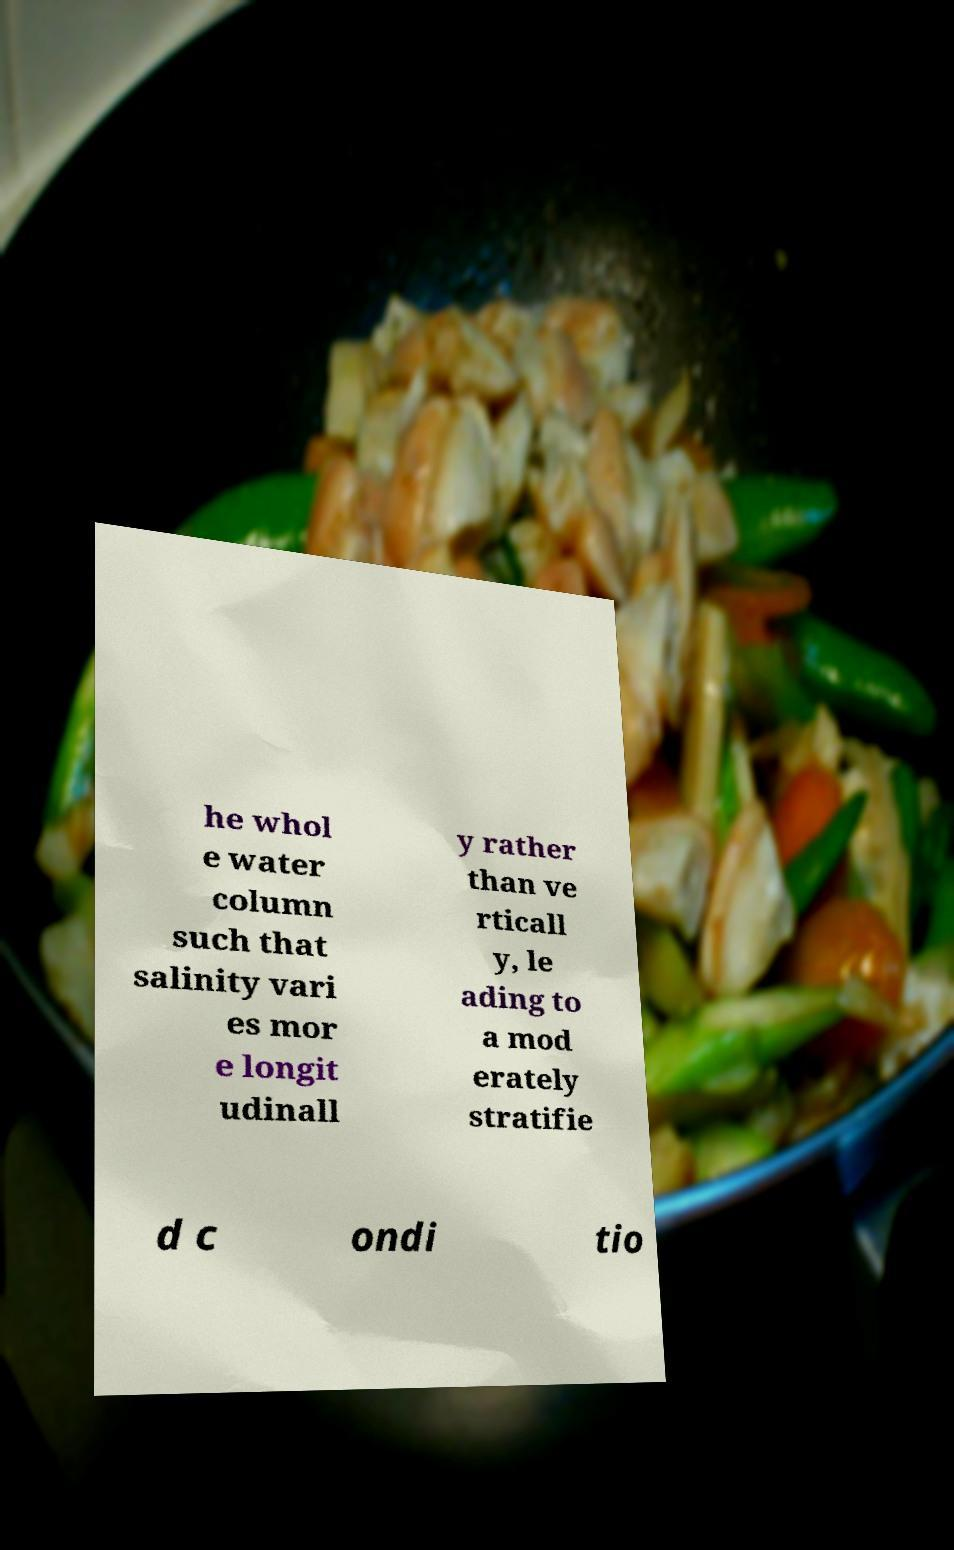Could you extract and type out the text from this image? he whol e water column such that salinity vari es mor e longit udinall y rather than ve rticall y, le ading to a mod erately stratifie d c ondi tio 